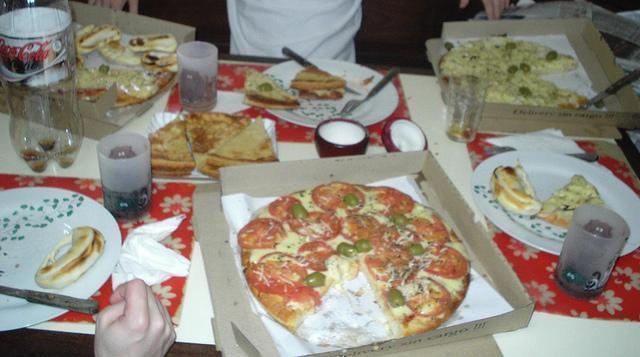How many slices of pizza are missing?
Give a very brief answer. 1. How many plates are on the table?
Give a very brief answer. 3. How many people are there?
Give a very brief answer. 2. How many pizzas can be seen?
Give a very brief answer. 4. How many cups are there?
Give a very brief answer. 4. How many open umbrellas are there?
Give a very brief answer. 0. 